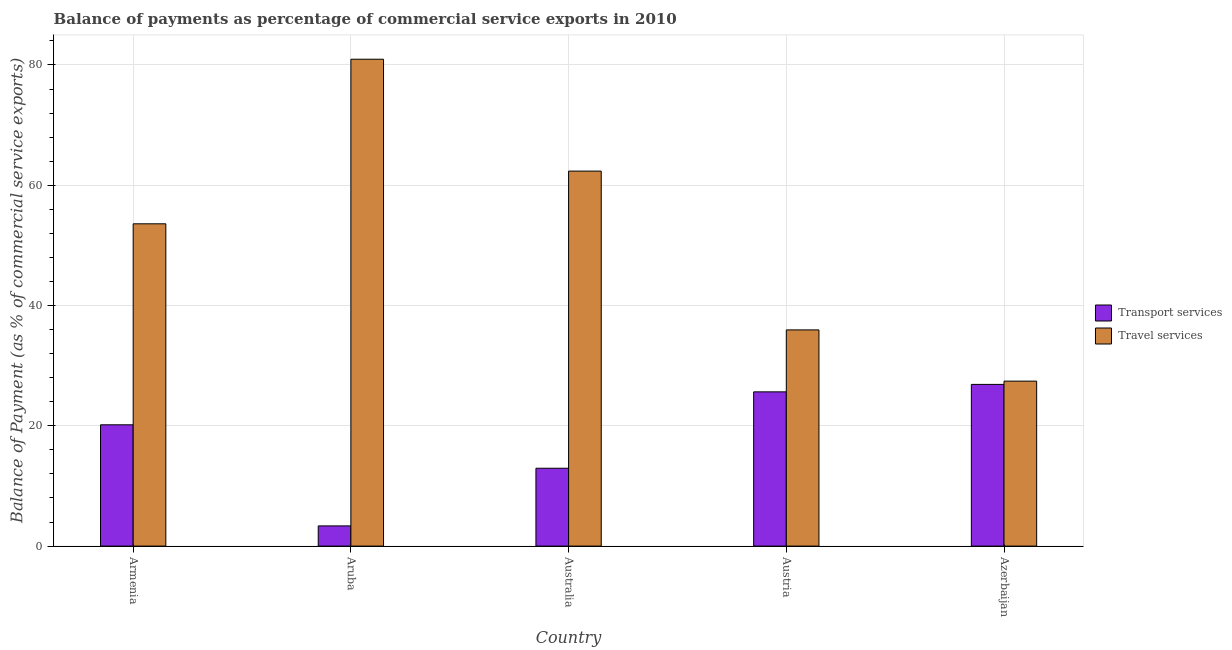How many different coloured bars are there?
Your answer should be compact. 2. Are the number of bars per tick equal to the number of legend labels?
Make the answer very short. Yes. How many bars are there on the 3rd tick from the left?
Offer a very short reply. 2. How many bars are there on the 5th tick from the right?
Offer a very short reply. 2. What is the label of the 2nd group of bars from the left?
Offer a terse response. Aruba. In how many cases, is the number of bars for a given country not equal to the number of legend labels?
Ensure brevity in your answer.  0. What is the balance of payments of travel services in Aruba?
Your answer should be compact. 80.95. Across all countries, what is the maximum balance of payments of transport services?
Make the answer very short. 26.89. Across all countries, what is the minimum balance of payments of transport services?
Give a very brief answer. 3.36. In which country was the balance of payments of travel services maximum?
Your answer should be very brief. Aruba. In which country was the balance of payments of transport services minimum?
Offer a terse response. Aruba. What is the total balance of payments of transport services in the graph?
Make the answer very short. 89.01. What is the difference between the balance of payments of travel services in Aruba and that in Austria?
Your answer should be compact. 45.01. What is the difference between the balance of payments of transport services in Aruba and the balance of payments of travel services in Azerbaijan?
Your answer should be very brief. -24.07. What is the average balance of payments of transport services per country?
Provide a short and direct response. 17.8. What is the difference between the balance of payments of travel services and balance of payments of transport services in Austria?
Offer a terse response. 10.3. What is the ratio of the balance of payments of travel services in Armenia to that in Azerbaijan?
Offer a very short reply. 1.95. Is the difference between the balance of payments of transport services in Armenia and Aruba greater than the difference between the balance of payments of travel services in Armenia and Aruba?
Provide a short and direct response. Yes. What is the difference between the highest and the second highest balance of payments of transport services?
Your answer should be very brief. 1.24. What is the difference between the highest and the lowest balance of payments of transport services?
Ensure brevity in your answer.  23.53. Is the sum of the balance of payments of transport services in Australia and Azerbaijan greater than the maximum balance of payments of travel services across all countries?
Ensure brevity in your answer.  No. What does the 2nd bar from the left in Azerbaijan represents?
Offer a terse response. Travel services. What does the 2nd bar from the right in Australia represents?
Provide a short and direct response. Transport services. Are all the bars in the graph horizontal?
Ensure brevity in your answer.  No. How many countries are there in the graph?
Keep it short and to the point. 5. Does the graph contain any zero values?
Ensure brevity in your answer.  No. Does the graph contain grids?
Your response must be concise. Yes. Where does the legend appear in the graph?
Your answer should be very brief. Center right. How many legend labels are there?
Ensure brevity in your answer.  2. How are the legend labels stacked?
Ensure brevity in your answer.  Vertical. What is the title of the graph?
Your answer should be very brief. Balance of payments as percentage of commercial service exports in 2010. What is the label or title of the Y-axis?
Give a very brief answer. Balance of Payment (as % of commercial service exports). What is the Balance of Payment (as % of commercial service exports) of Transport services in Armenia?
Offer a very short reply. 20.17. What is the Balance of Payment (as % of commercial service exports) of Travel services in Armenia?
Give a very brief answer. 53.59. What is the Balance of Payment (as % of commercial service exports) of Transport services in Aruba?
Provide a succinct answer. 3.36. What is the Balance of Payment (as % of commercial service exports) in Travel services in Aruba?
Make the answer very short. 80.95. What is the Balance of Payment (as % of commercial service exports) of Transport services in Australia?
Make the answer very short. 12.94. What is the Balance of Payment (as % of commercial service exports) of Travel services in Australia?
Ensure brevity in your answer.  62.35. What is the Balance of Payment (as % of commercial service exports) of Transport services in Austria?
Make the answer very short. 25.65. What is the Balance of Payment (as % of commercial service exports) of Travel services in Austria?
Your response must be concise. 35.95. What is the Balance of Payment (as % of commercial service exports) of Transport services in Azerbaijan?
Offer a very short reply. 26.89. What is the Balance of Payment (as % of commercial service exports) in Travel services in Azerbaijan?
Keep it short and to the point. 27.43. Across all countries, what is the maximum Balance of Payment (as % of commercial service exports) in Transport services?
Ensure brevity in your answer.  26.89. Across all countries, what is the maximum Balance of Payment (as % of commercial service exports) of Travel services?
Offer a terse response. 80.95. Across all countries, what is the minimum Balance of Payment (as % of commercial service exports) of Transport services?
Your response must be concise. 3.36. Across all countries, what is the minimum Balance of Payment (as % of commercial service exports) of Travel services?
Your answer should be very brief. 27.43. What is the total Balance of Payment (as % of commercial service exports) in Transport services in the graph?
Your answer should be very brief. 89.01. What is the total Balance of Payment (as % of commercial service exports) of Travel services in the graph?
Your answer should be compact. 260.27. What is the difference between the Balance of Payment (as % of commercial service exports) in Transport services in Armenia and that in Aruba?
Provide a succinct answer. 16.81. What is the difference between the Balance of Payment (as % of commercial service exports) in Travel services in Armenia and that in Aruba?
Offer a very short reply. -27.37. What is the difference between the Balance of Payment (as % of commercial service exports) of Transport services in Armenia and that in Australia?
Keep it short and to the point. 7.22. What is the difference between the Balance of Payment (as % of commercial service exports) in Travel services in Armenia and that in Australia?
Your response must be concise. -8.76. What is the difference between the Balance of Payment (as % of commercial service exports) in Transport services in Armenia and that in Austria?
Provide a short and direct response. -5.48. What is the difference between the Balance of Payment (as % of commercial service exports) in Travel services in Armenia and that in Austria?
Make the answer very short. 17.64. What is the difference between the Balance of Payment (as % of commercial service exports) in Transport services in Armenia and that in Azerbaijan?
Offer a very short reply. -6.72. What is the difference between the Balance of Payment (as % of commercial service exports) of Travel services in Armenia and that in Azerbaijan?
Your response must be concise. 26.16. What is the difference between the Balance of Payment (as % of commercial service exports) in Transport services in Aruba and that in Australia?
Offer a terse response. -9.59. What is the difference between the Balance of Payment (as % of commercial service exports) in Travel services in Aruba and that in Australia?
Your answer should be compact. 18.6. What is the difference between the Balance of Payment (as % of commercial service exports) in Transport services in Aruba and that in Austria?
Keep it short and to the point. -22.29. What is the difference between the Balance of Payment (as % of commercial service exports) of Travel services in Aruba and that in Austria?
Offer a very short reply. 45.01. What is the difference between the Balance of Payment (as % of commercial service exports) of Transport services in Aruba and that in Azerbaijan?
Ensure brevity in your answer.  -23.53. What is the difference between the Balance of Payment (as % of commercial service exports) in Travel services in Aruba and that in Azerbaijan?
Provide a succinct answer. 53.53. What is the difference between the Balance of Payment (as % of commercial service exports) of Transport services in Australia and that in Austria?
Make the answer very short. -12.7. What is the difference between the Balance of Payment (as % of commercial service exports) in Travel services in Australia and that in Austria?
Offer a terse response. 26.4. What is the difference between the Balance of Payment (as % of commercial service exports) of Transport services in Australia and that in Azerbaijan?
Provide a short and direct response. -13.94. What is the difference between the Balance of Payment (as % of commercial service exports) in Travel services in Australia and that in Azerbaijan?
Your answer should be very brief. 34.92. What is the difference between the Balance of Payment (as % of commercial service exports) in Transport services in Austria and that in Azerbaijan?
Provide a short and direct response. -1.24. What is the difference between the Balance of Payment (as % of commercial service exports) in Travel services in Austria and that in Azerbaijan?
Give a very brief answer. 8.52. What is the difference between the Balance of Payment (as % of commercial service exports) of Transport services in Armenia and the Balance of Payment (as % of commercial service exports) of Travel services in Aruba?
Provide a succinct answer. -60.79. What is the difference between the Balance of Payment (as % of commercial service exports) of Transport services in Armenia and the Balance of Payment (as % of commercial service exports) of Travel services in Australia?
Provide a short and direct response. -42.18. What is the difference between the Balance of Payment (as % of commercial service exports) of Transport services in Armenia and the Balance of Payment (as % of commercial service exports) of Travel services in Austria?
Provide a succinct answer. -15.78. What is the difference between the Balance of Payment (as % of commercial service exports) in Transport services in Armenia and the Balance of Payment (as % of commercial service exports) in Travel services in Azerbaijan?
Your response must be concise. -7.26. What is the difference between the Balance of Payment (as % of commercial service exports) of Transport services in Aruba and the Balance of Payment (as % of commercial service exports) of Travel services in Australia?
Your answer should be very brief. -58.99. What is the difference between the Balance of Payment (as % of commercial service exports) of Transport services in Aruba and the Balance of Payment (as % of commercial service exports) of Travel services in Austria?
Offer a very short reply. -32.59. What is the difference between the Balance of Payment (as % of commercial service exports) of Transport services in Aruba and the Balance of Payment (as % of commercial service exports) of Travel services in Azerbaijan?
Make the answer very short. -24.07. What is the difference between the Balance of Payment (as % of commercial service exports) of Transport services in Australia and the Balance of Payment (as % of commercial service exports) of Travel services in Austria?
Provide a succinct answer. -23. What is the difference between the Balance of Payment (as % of commercial service exports) of Transport services in Australia and the Balance of Payment (as % of commercial service exports) of Travel services in Azerbaijan?
Provide a succinct answer. -14.48. What is the difference between the Balance of Payment (as % of commercial service exports) in Transport services in Austria and the Balance of Payment (as % of commercial service exports) in Travel services in Azerbaijan?
Ensure brevity in your answer.  -1.78. What is the average Balance of Payment (as % of commercial service exports) in Transport services per country?
Provide a succinct answer. 17.8. What is the average Balance of Payment (as % of commercial service exports) in Travel services per country?
Your answer should be compact. 52.05. What is the difference between the Balance of Payment (as % of commercial service exports) in Transport services and Balance of Payment (as % of commercial service exports) in Travel services in Armenia?
Give a very brief answer. -33.42. What is the difference between the Balance of Payment (as % of commercial service exports) of Transport services and Balance of Payment (as % of commercial service exports) of Travel services in Aruba?
Your answer should be compact. -77.6. What is the difference between the Balance of Payment (as % of commercial service exports) in Transport services and Balance of Payment (as % of commercial service exports) in Travel services in Australia?
Provide a short and direct response. -49.41. What is the difference between the Balance of Payment (as % of commercial service exports) in Transport services and Balance of Payment (as % of commercial service exports) in Travel services in Austria?
Provide a succinct answer. -10.3. What is the difference between the Balance of Payment (as % of commercial service exports) in Transport services and Balance of Payment (as % of commercial service exports) in Travel services in Azerbaijan?
Offer a terse response. -0.54. What is the ratio of the Balance of Payment (as % of commercial service exports) in Transport services in Armenia to that in Aruba?
Your answer should be very brief. 6.01. What is the ratio of the Balance of Payment (as % of commercial service exports) of Travel services in Armenia to that in Aruba?
Provide a succinct answer. 0.66. What is the ratio of the Balance of Payment (as % of commercial service exports) of Transport services in Armenia to that in Australia?
Provide a succinct answer. 1.56. What is the ratio of the Balance of Payment (as % of commercial service exports) of Travel services in Armenia to that in Australia?
Keep it short and to the point. 0.86. What is the ratio of the Balance of Payment (as % of commercial service exports) of Transport services in Armenia to that in Austria?
Give a very brief answer. 0.79. What is the ratio of the Balance of Payment (as % of commercial service exports) in Travel services in Armenia to that in Austria?
Your answer should be compact. 1.49. What is the ratio of the Balance of Payment (as % of commercial service exports) in Transport services in Armenia to that in Azerbaijan?
Give a very brief answer. 0.75. What is the ratio of the Balance of Payment (as % of commercial service exports) in Travel services in Armenia to that in Azerbaijan?
Your response must be concise. 1.95. What is the ratio of the Balance of Payment (as % of commercial service exports) in Transport services in Aruba to that in Australia?
Make the answer very short. 0.26. What is the ratio of the Balance of Payment (as % of commercial service exports) of Travel services in Aruba to that in Australia?
Ensure brevity in your answer.  1.3. What is the ratio of the Balance of Payment (as % of commercial service exports) of Transport services in Aruba to that in Austria?
Offer a very short reply. 0.13. What is the ratio of the Balance of Payment (as % of commercial service exports) in Travel services in Aruba to that in Austria?
Your response must be concise. 2.25. What is the ratio of the Balance of Payment (as % of commercial service exports) in Transport services in Aruba to that in Azerbaijan?
Offer a very short reply. 0.12. What is the ratio of the Balance of Payment (as % of commercial service exports) in Travel services in Aruba to that in Azerbaijan?
Offer a terse response. 2.95. What is the ratio of the Balance of Payment (as % of commercial service exports) of Transport services in Australia to that in Austria?
Make the answer very short. 0.5. What is the ratio of the Balance of Payment (as % of commercial service exports) in Travel services in Australia to that in Austria?
Ensure brevity in your answer.  1.73. What is the ratio of the Balance of Payment (as % of commercial service exports) in Transport services in Australia to that in Azerbaijan?
Your response must be concise. 0.48. What is the ratio of the Balance of Payment (as % of commercial service exports) in Travel services in Australia to that in Azerbaijan?
Provide a short and direct response. 2.27. What is the ratio of the Balance of Payment (as % of commercial service exports) in Transport services in Austria to that in Azerbaijan?
Your response must be concise. 0.95. What is the ratio of the Balance of Payment (as % of commercial service exports) of Travel services in Austria to that in Azerbaijan?
Your response must be concise. 1.31. What is the difference between the highest and the second highest Balance of Payment (as % of commercial service exports) of Transport services?
Ensure brevity in your answer.  1.24. What is the difference between the highest and the second highest Balance of Payment (as % of commercial service exports) in Travel services?
Keep it short and to the point. 18.6. What is the difference between the highest and the lowest Balance of Payment (as % of commercial service exports) in Transport services?
Your response must be concise. 23.53. What is the difference between the highest and the lowest Balance of Payment (as % of commercial service exports) in Travel services?
Provide a succinct answer. 53.53. 